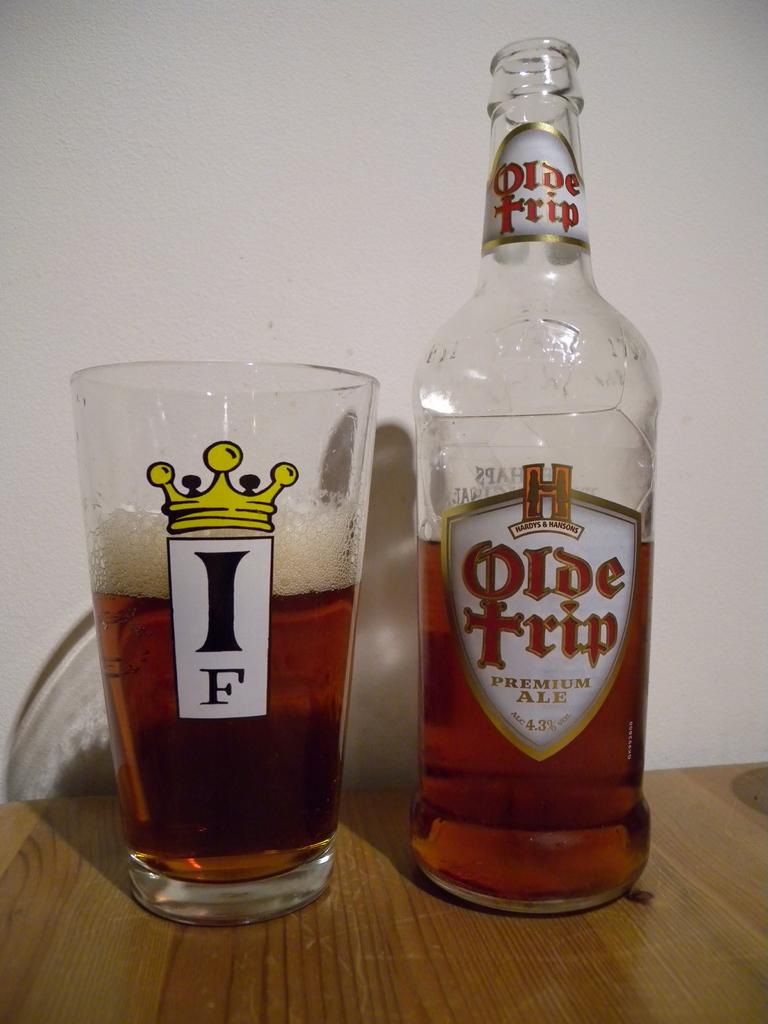<image>
Create a compact narrative representing the image presented. A glass half full of Olde Trip premium ale sits on a wooden table next to the bottle it was poured from. 